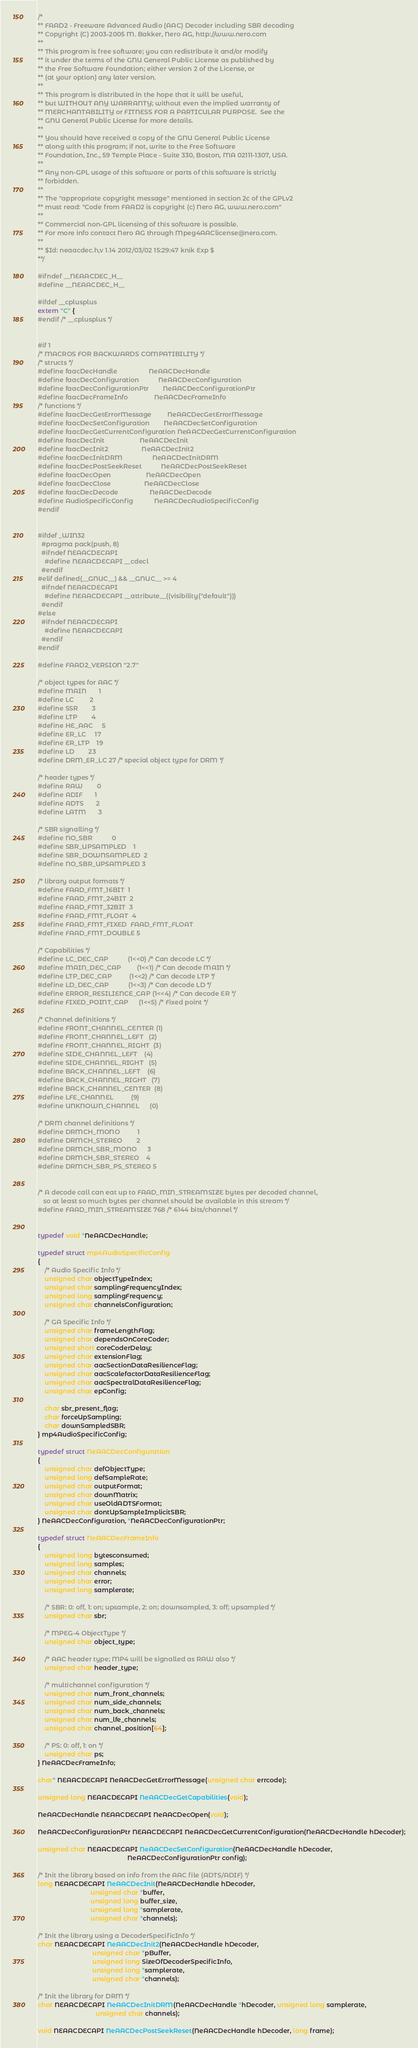<code> <loc_0><loc_0><loc_500><loc_500><_C_>/*
** FAAD2 - Freeware Advanced Audio (AAC) Decoder including SBR decoding
** Copyright (C) 2003-2005 M. Bakker, Nero AG, http://www.nero.com
**  
** This program is free software; you can redistribute it and/or modify
** it under the terms of the GNU General Public License as published by
** the Free Software Foundation; either version 2 of the License, or
** (at your option) any later version.
** 
** This program is distributed in the hope that it will be useful,
** but WITHOUT ANY WARRANTY; without even the implied warranty of
** MERCHANTABILITY or FITNESS FOR A PARTICULAR PURPOSE.  See the
** GNU General Public License for more details.
** 
** You should have received a copy of the GNU General Public License
** along with this program; if not, write to the Free Software 
** Foundation, Inc., 59 Temple Place - Suite 330, Boston, MA 02111-1307, USA.
**
** Any non-GPL usage of this software or parts of this software is strictly
** forbidden.
**
** The "appropriate copyright message" mentioned in section 2c of the GPLv2
** must read: "Code from FAAD2 is copyright (c) Nero AG, www.nero.com"
**
** Commercial non-GPL licensing of this software is possible.
** For more info contact Nero AG through Mpeg4AAClicense@nero.com.
**
** $Id: neaacdec.h,v 1.14 2012/03/02 15:29:47 knik Exp $
**/

#ifndef __NEAACDEC_H__
#define __NEAACDEC_H__

#ifdef __cplusplus
extern "C" {
#endif /* __cplusplus */


#if 1
/* MACROS FOR BACKWARDS COMPATIBILITY */
/* structs */
#define faacDecHandle                  NeAACDecHandle
#define faacDecConfiguration           NeAACDecConfiguration
#define faacDecConfigurationPtr        NeAACDecConfigurationPtr
#define faacDecFrameInfo               NeAACDecFrameInfo
/* functions */
#define faacDecGetErrorMessage         NeAACDecGetErrorMessage
#define faacDecSetConfiguration        NeAACDecSetConfiguration
#define faacDecGetCurrentConfiguration NeAACDecGetCurrentConfiguration
#define faacDecInit                    NeAACDecInit
#define faacDecInit2                   NeAACDecInit2
#define faacDecInitDRM                 NeAACDecInitDRM
#define faacDecPostSeekReset           NeAACDecPostSeekReset
#define faacDecOpen                    NeAACDecOpen
#define faacDecClose                   NeAACDecClose
#define faacDecDecode                  NeAACDecDecode
#define AudioSpecificConfig            NeAACDecAudioSpecificConfig
#endif


#ifdef _WIN32
  #pragma pack(push, 8)
  #ifndef NEAACDECAPI
    #define NEAACDECAPI __cdecl
  #endif
#elif defined(__GNUC__) && __GNUC__ >= 4
  #ifndef NEAACDECAPI
    #define NEAACDECAPI __attribute__((visibility("default")))
  #endif
#else
  #ifndef NEAACDECAPI
    #define NEAACDECAPI
  #endif
#endif

#define FAAD2_VERSION "2.7"

/* object types for AAC */
#define MAIN       1
#define LC         2
#define SSR        3
#define LTP        4
#define HE_AAC     5
#define ER_LC     17
#define ER_LTP    19
#define LD        23
#define DRM_ER_LC 27 /* special object type for DRM */

/* header types */
#define RAW        0
#define ADIF       1
#define ADTS       2
#define LATM       3

/* SBR signalling */
#define NO_SBR           0
#define SBR_UPSAMPLED    1
#define SBR_DOWNSAMPLED  2
#define NO_SBR_UPSAMPLED 3

/* library output formats */
#define FAAD_FMT_16BIT  1
#define FAAD_FMT_24BIT  2
#define FAAD_FMT_32BIT  3
#define FAAD_FMT_FLOAT  4
#define FAAD_FMT_FIXED  FAAD_FMT_FLOAT
#define FAAD_FMT_DOUBLE 5

/* Capabilities */
#define LC_DEC_CAP           (1<<0) /* Can decode LC */
#define MAIN_DEC_CAP         (1<<1) /* Can decode MAIN */
#define LTP_DEC_CAP          (1<<2) /* Can decode LTP */
#define LD_DEC_CAP           (1<<3) /* Can decode LD */
#define ERROR_RESILIENCE_CAP (1<<4) /* Can decode ER */
#define FIXED_POINT_CAP      (1<<5) /* Fixed point */

/* Channel definitions */
#define FRONT_CHANNEL_CENTER (1)
#define FRONT_CHANNEL_LEFT   (2)
#define FRONT_CHANNEL_RIGHT  (3)
#define SIDE_CHANNEL_LEFT    (4)
#define SIDE_CHANNEL_RIGHT   (5)
#define BACK_CHANNEL_LEFT    (6)
#define BACK_CHANNEL_RIGHT   (7)
#define BACK_CHANNEL_CENTER  (8)
#define LFE_CHANNEL          (9)
#define UNKNOWN_CHANNEL      (0)

/* DRM channel definitions */
#define DRMCH_MONO          1
#define DRMCH_STEREO        2
#define DRMCH_SBR_MONO      3
#define DRMCH_SBR_STEREO    4
#define DRMCH_SBR_PS_STEREO 5


/* A decode call can eat up to FAAD_MIN_STREAMSIZE bytes per decoded channel,
   so at least so much bytes per channel should be available in this stream */
#define FAAD_MIN_STREAMSIZE 768 /* 6144 bits/channel */


typedef void *NeAACDecHandle;

typedef struct mp4AudioSpecificConfig
{
    /* Audio Specific Info */
    unsigned char objectTypeIndex;
    unsigned char samplingFrequencyIndex;
    unsigned long samplingFrequency;
    unsigned char channelsConfiguration;

    /* GA Specific Info */
    unsigned char frameLengthFlag;
    unsigned char dependsOnCoreCoder;
    unsigned short coreCoderDelay;
    unsigned char extensionFlag;
    unsigned char aacSectionDataResilienceFlag;
    unsigned char aacScalefactorDataResilienceFlag;
    unsigned char aacSpectralDataResilienceFlag;
    unsigned char epConfig;

    char sbr_present_flag;
    char forceUpSampling;
    char downSampledSBR;
} mp4AudioSpecificConfig;

typedef struct NeAACDecConfiguration
{
    unsigned char defObjectType;
    unsigned long defSampleRate;
    unsigned char outputFormat;
    unsigned char downMatrix;
    unsigned char useOldADTSFormat;
    unsigned char dontUpSampleImplicitSBR;
} NeAACDecConfiguration, *NeAACDecConfigurationPtr;

typedef struct NeAACDecFrameInfo
{
    unsigned long bytesconsumed;
    unsigned long samples;
    unsigned char channels;
    unsigned char error;
    unsigned long samplerate;

    /* SBR: 0: off, 1: on; upsample, 2: on; downsampled, 3: off; upsampled */
    unsigned char sbr;

    /* MPEG-4 ObjectType */
    unsigned char object_type;

    /* AAC header type; MP4 will be signalled as RAW also */
    unsigned char header_type;

    /* multichannel configuration */
    unsigned char num_front_channels;
    unsigned char num_side_channels;
    unsigned char num_back_channels;
    unsigned char num_lfe_channels;
    unsigned char channel_position[64];

    /* PS: 0: off, 1: on */
    unsigned char ps;
} NeAACDecFrameInfo;

char* NEAACDECAPI NeAACDecGetErrorMessage(unsigned char errcode);

unsigned long NEAACDECAPI NeAACDecGetCapabilities(void);

NeAACDecHandle NEAACDECAPI NeAACDecOpen(void);

NeAACDecConfigurationPtr NEAACDECAPI NeAACDecGetCurrentConfiguration(NeAACDecHandle hDecoder);

unsigned char NEAACDECAPI NeAACDecSetConfiguration(NeAACDecHandle hDecoder,
                                                   NeAACDecConfigurationPtr config);

/* Init the library based on info from the AAC file (ADTS/ADIF) */
long NEAACDECAPI NeAACDecInit(NeAACDecHandle hDecoder,
                              unsigned char *buffer,
                              unsigned long buffer_size,
                              unsigned long *samplerate,
                              unsigned char *channels);

/* Init the library using a DecoderSpecificInfo */
char NEAACDECAPI NeAACDecInit2(NeAACDecHandle hDecoder,
                               unsigned char *pBuffer,
                               unsigned long SizeOfDecoderSpecificInfo,
                               unsigned long *samplerate,
                               unsigned char *channels);

/* Init the library for DRM */
char NEAACDECAPI NeAACDecInitDRM(NeAACDecHandle *hDecoder, unsigned long samplerate,
                                 unsigned char channels);

void NEAACDECAPI NeAACDecPostSeekReset(NeAACDecHandle hDecoder, long frame);
</code> 